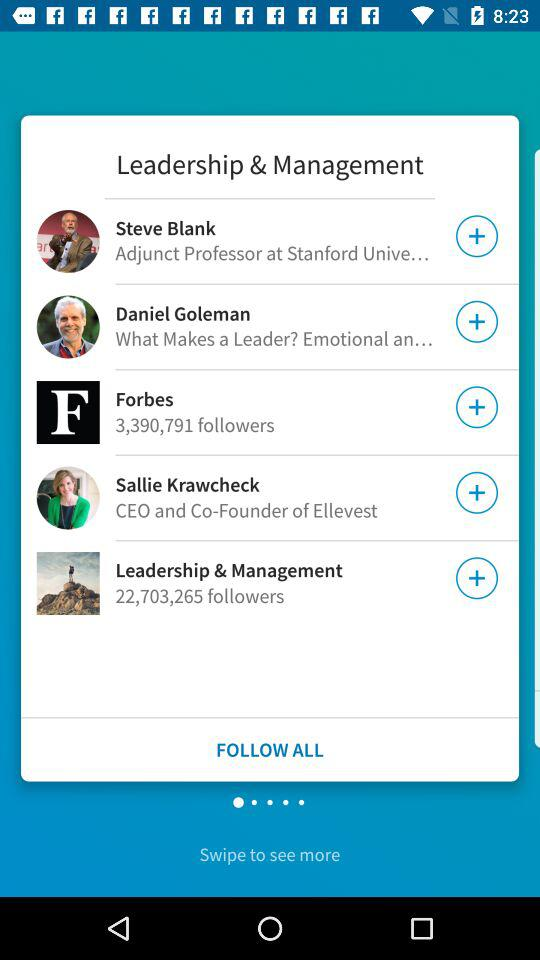How many followers are there for Forbes? There are 3,390,791 followers. 